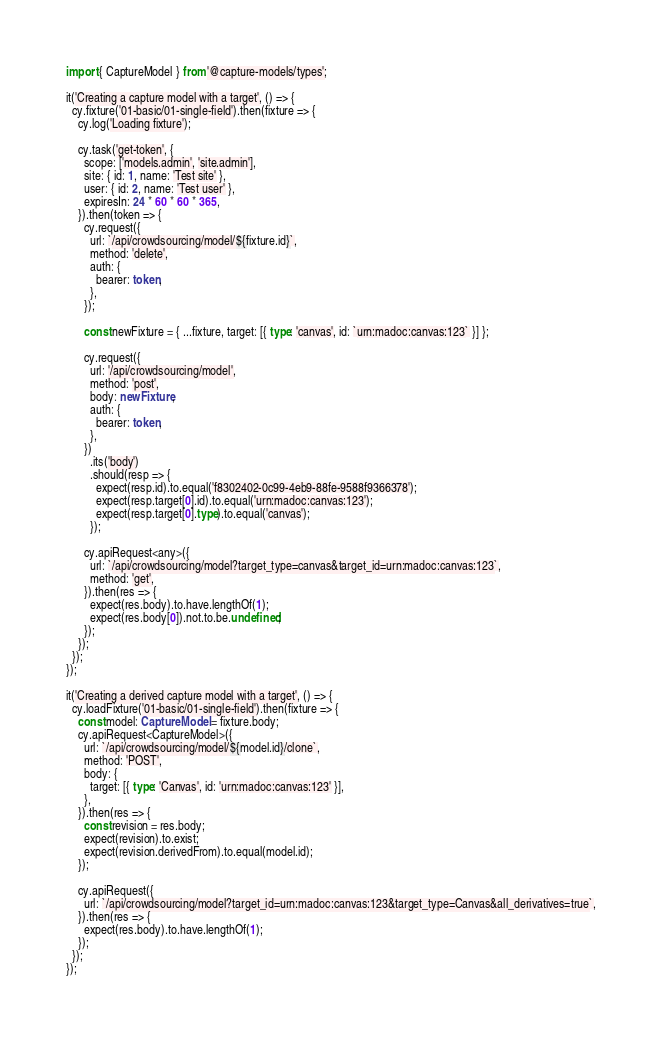Convert code to text. <code><loc_0><loc_0><loc_500><loc_500><_TypeScript_>import { CaptureModel } from '@capture-models/types';

it('Creating a capture model with a target', () => {
  cy.fixture('01-basic/01-single-field').then(fixture => {
    cy.log('Loading fixture');

    cy.task('get-token', {
      scope: ['models.admin', 'site.admin'],
      site: { id: 1, name: 'Test site' },
      user: { id: 2, name: 'Test user' },
      expiresIn: 24 * 60 * 60 * 365,
    }).then(token => {
      cy.request({
        url: `/api/crowdsourcing/model/${fixture.id}`,
        method: 'delete',
        auth: {
          bearer: token,
        },
      });

      const newFixture = { ...fixture, target: [{ type: 'canvas', id: `urn:madoc:canvas:123` }] };

      cy.request({
        url: '/api/crowdsourcing/model',
        method: 'post',
        body: newFixture,
        auth: {
          bearer: token,
        },
      })
        .its('body')
        .should(resp => {
          expect(resp.id).to.equal('f8302402-0c99-4eb9-88fe-9588f9366378');
          expect(resp.target[0].id).to.equal('urn:madoc:canvas:123');
          expect(resp.target[0].type).to.equal('canvas');
        });

      cy.apiRequest<any>({
        url: `/api/crowdsourcing/model?target_type=canvas&target_id=urn:madoc:canvas:123`,
        method: 'get',
      }).then(res => {
        expect(res.body).to.have.lengthOf(1);
        expect(res.body[0]).not.to.be.undefined;
      });
    });
  });
});

it('Creating a derived capture model with a target', () => {
  cy.loadFixture('01-basic/01-single-field').then(fixture => {
    const model: CaptureModel = fixture.body;
    cy.apiRequest<CaptureModel>({
      url: `/api/crowdsourcing/model/${model.id}/clone`,
      method: 'POST',
      body: {
        target: [{ type: 'Canvas', id: 'urn:madoc:canvas:123' }],
      },
    }).then(res => {
      const revision = res.body;
      expect(revision).to.exist;
      expect(revision.derivedFrom).to.equal(model.id);
    });

    cy.apiRequest({
      url: `/api/crowdsourcing/model?target_id=urn:madoc:canvas:123&target_type=Canvas&all_derivatives=true`,
    }).then(res => {
      expect(res.body).to.have.lengthOf(1);
    });
  });
});
</code> 